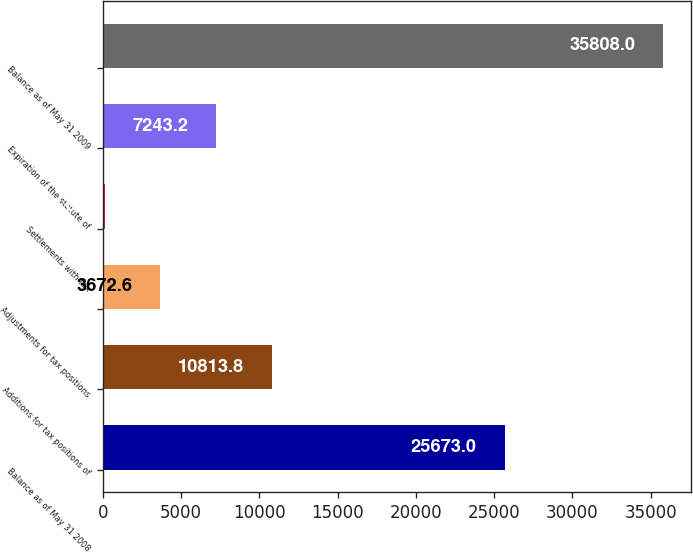Convert chart to OTSL. <chart><loc_0><loc_0><loc_500><loc_500><bar_chart><fcel>Balance as of May 31 2008<fcel>Additions for tax positions of<fcel>Adjustments for tax positions<fcel>Settlements with tax<fcel>Expiration of the statute of<fcel>Balance as of May 31 2009<nl><fcel>25673<fcel>10813.8<fcel>3672.6<fcel>102<fcel>7243.2<fcel>35808<nl></chart> 